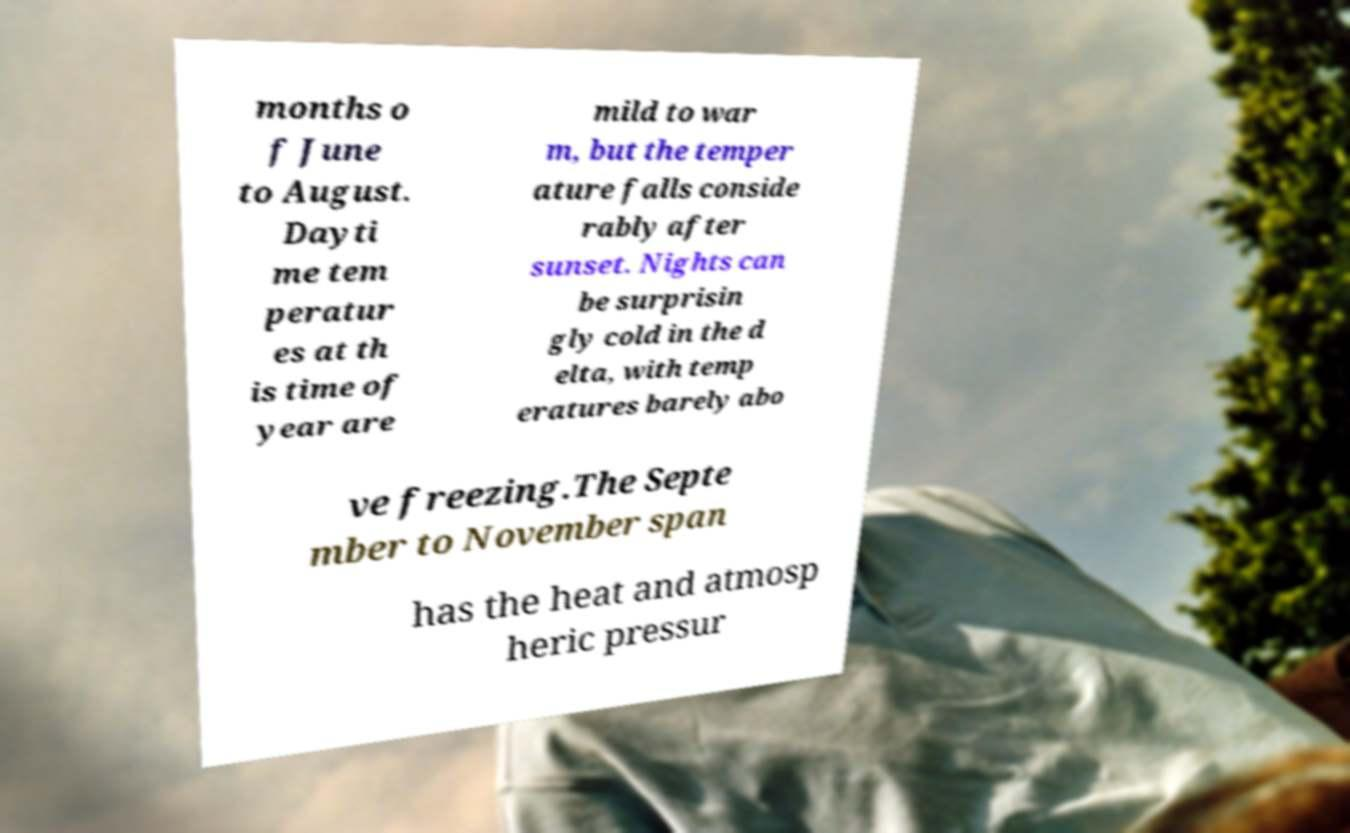For documentation purposes, I need the text within this image transcribed. Could you provide that? months o f June to August. Dayti me tem peratur es at th is time of year are mild to war m, but the temper ature falls conside rably after sunset. Nights can be surprisin gly cold in the d elta, with temp eratures barely abo ve freezing.The Septe mber to November span has the heat and atmosp heric pressur 